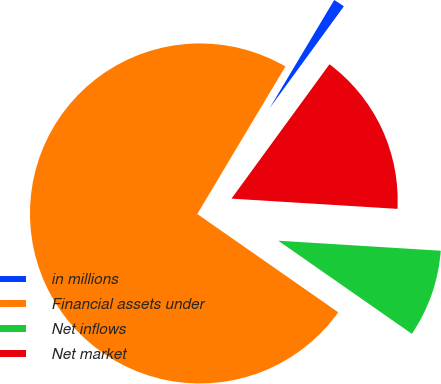Convert chart to OTSL. <chart><loc_0><loc_0><loc_500><loc_500><pie_chart><fcel>in millions<fcel>Financial assets under<fcel>Net inflows<fcel>Net market<nl><fcel>1.46%<fcel>73.88%<fcel>8.71%<fcel>15.95%<nl></chart> 